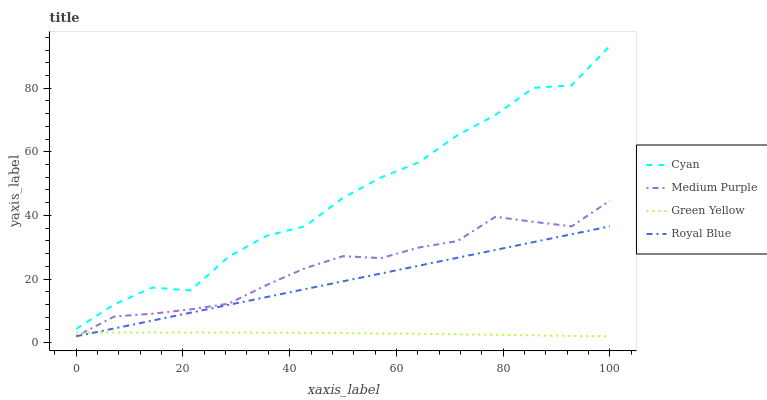Does Green Yellow have the minimum area under the curve?
Answer yes or no. Yes. Does Cyan have the maximum area under the curve?
Answer yes or no. Yes. Does Cyan have the minimum area under the curve?
Answer yes or no. No. Does Green Yellow have the maximum area under the curve?
Answer yes or no. No. Is Royal Blue the smoothest?
Answer yes or no. Yes. Is Cyan the roughest?
Answer yes or no. Yes. Is Green Yellow the smoothest?
Answer yes or no. No. Is Green Yellow the roughest?
Answer yes or no. No. Does Medium Purple have the lowest value?
Answer yes or no. Yes. Does Cyan have the lowest value?
Answer yes or no. No. Does Cyan have the highest value?
Answer yes or no. Yes. Does Green Yellow have the highest value?
Answer yes or no. No. Is Royal Blue less than Cyan?
Answer yes or no. Yes. Is Cyan greater than Medium Purple?
Answer yes or no. Yes. Does Royal Blue intersect Green Yellow?
Answer yes or no. Yes. Is Royal Blue less than Green Yellow?
Answer yes or no. No. Is Royal Blue greater than Green Yellow?
Answer yes or no. No. Does Royal Blue intersect Cyan?
Answer yes or no. No. 